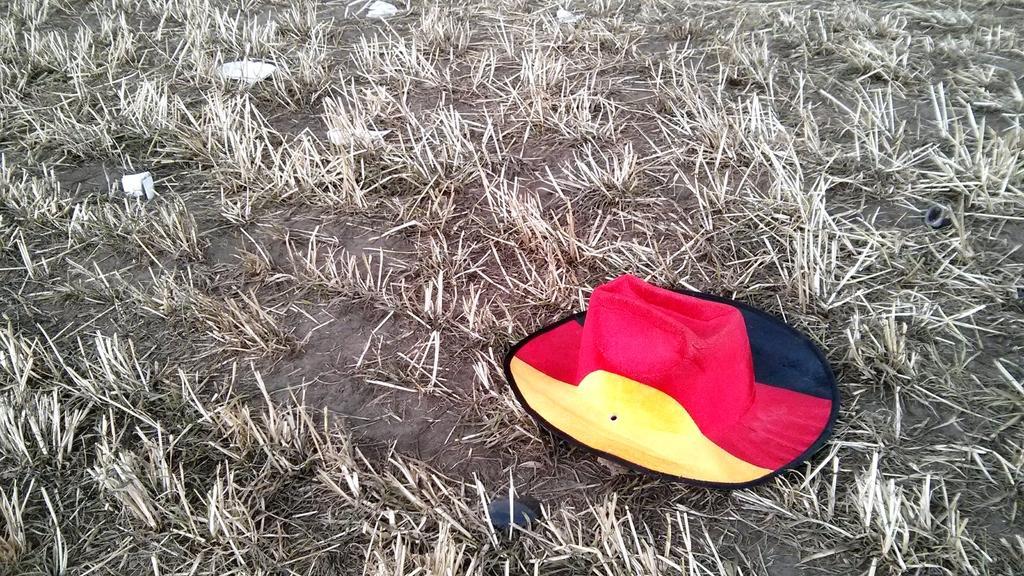Can you describe this image briefly? In the center of the image we can see one hat, which is in yellow, black and red color. In the background we can see the grass and a few other objects. 